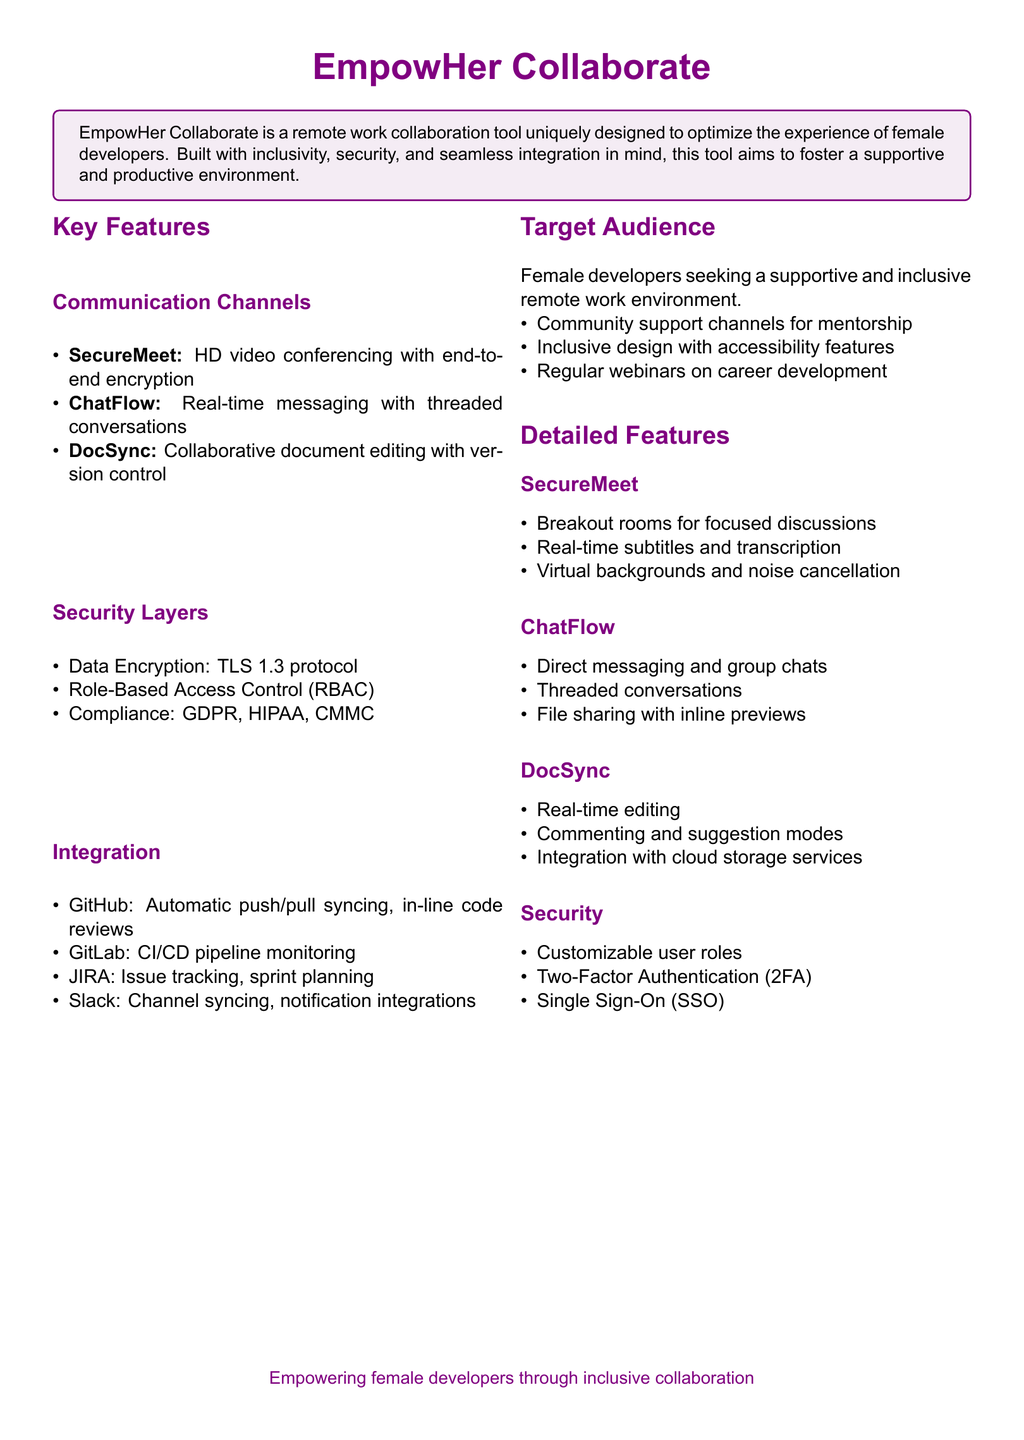What is the name of the collaboration tool? The name of the collaboration tool is mentioned prominently at the top of the document.
Answer: EmpowHer Collaborate What security compliance standards are mentioned? The document lists compliance standards in the security section.
Answer: GDPR, HIPAA, CMMC What feature allows for real-time document editing? The section detailing collaborative document editing identifies this feature.
Answer: DocSync What communication channel includes HD video conferencing? The section on communication channels specifies this feature.
Answer: SecureMeet How many communication channels are listed in the document? The document enumerates the communication channels under the key features section.
Answer: Three What is the purpose of the community support channels? The document states the intended use of community support channels under the target audience section.
Answer: Mentorship What real-time feature does ChatFlow offer besides messaging? The document describes additional capabilities of ChatFlow in its detailed features.
Answer: Threaded conversations What type of authentication is offered for enhanced security? The security section includes measures for securing user access.
Answer: Two-Factor Authentication What integration feature is included for GitHub? The integration section specifies the capabilities for GitHub.
Answer: Automatic push/pull syncing 